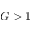<formula> <loc_0><loc_0><loc_500><loc_500>G > 1</formula> 